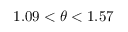<formula> <loc_0><loc_0><loc_500><loc_500>1 . 0 9 < \theta < 1 . 5 7</formula> 